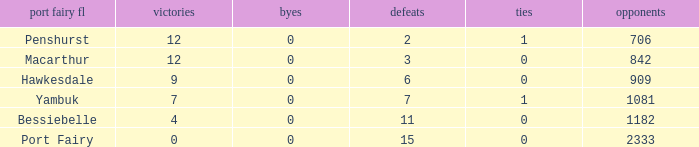How many wins for Port Fairy and against more than 2333? None. 